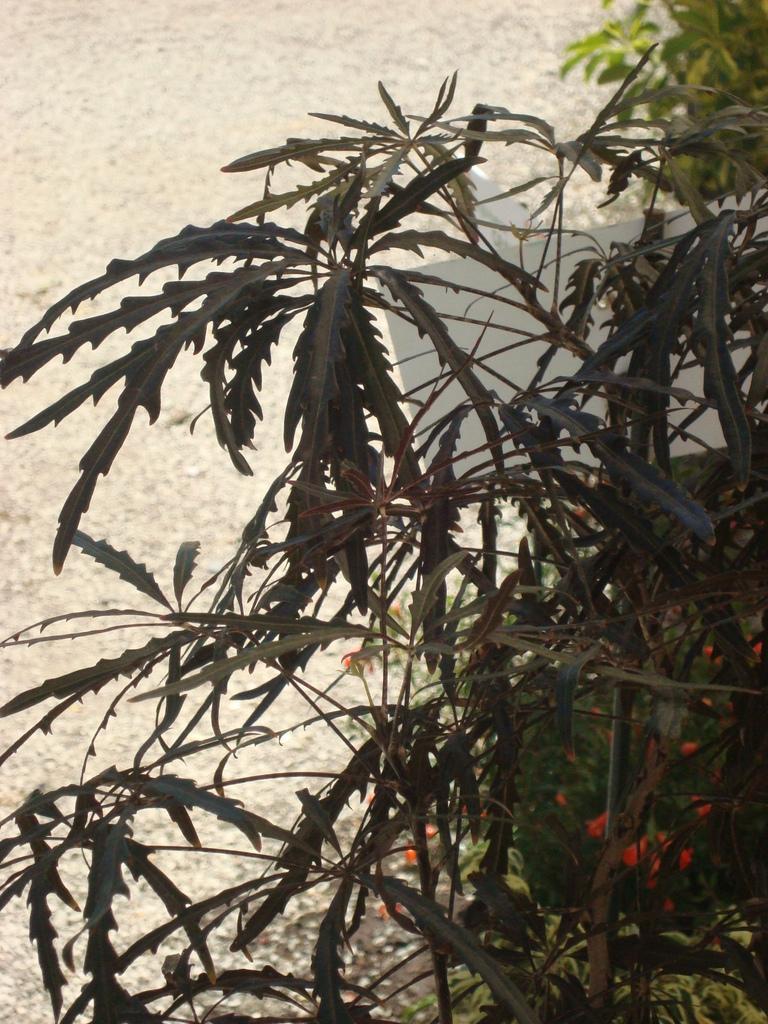In one or two sentences, can you explain what this image depicts? In this image, we can see some green color plants. 